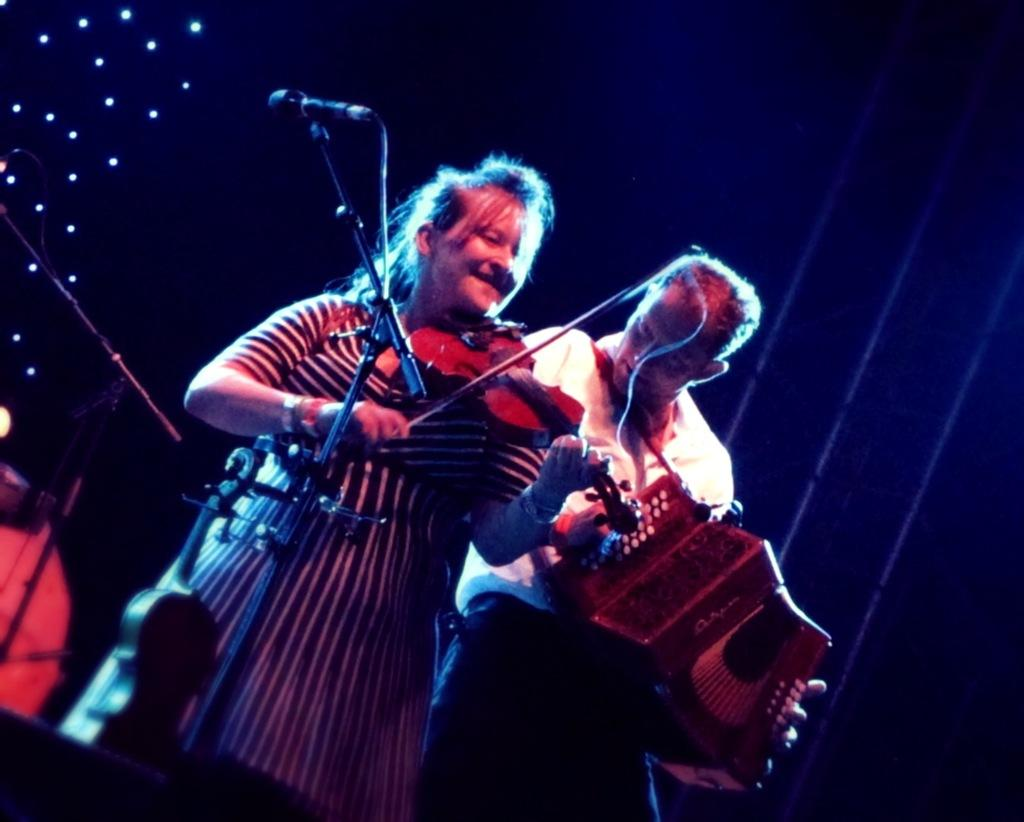What are the persons in the image doing? The persons in the image are standing and playing musical instruments. What might be used to amplify their voices? There are mics present in the image, which might be used to amplify their voices. What can be seen in the image that might provide illumination? There are lights visible in the image. How would you describe the overall lighting in the image? The background of the image is dark. What type of care can be seen being provided to the paper in the image? There is no paper present in the image, so no care can be provided to it. 